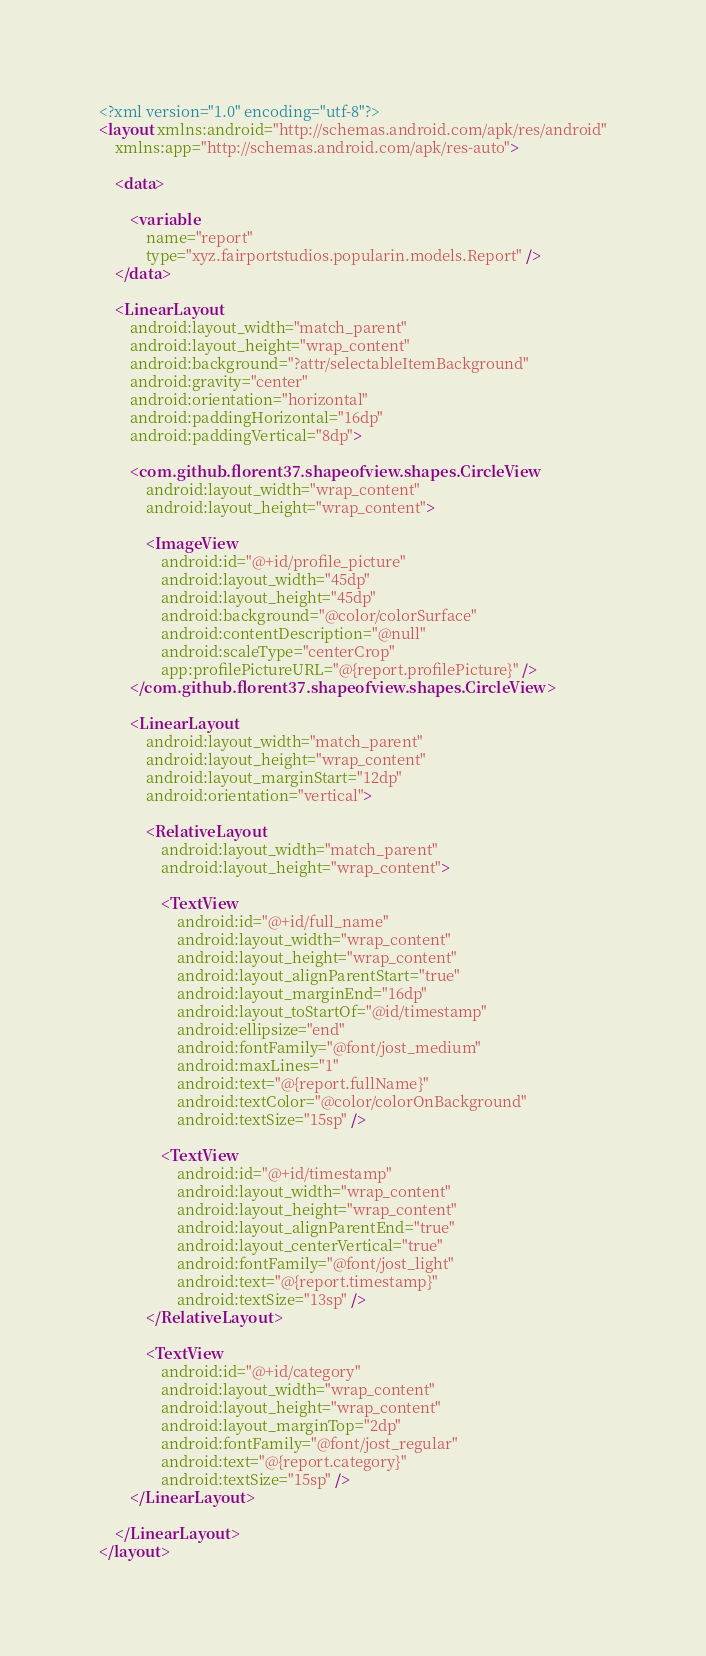<code> <loc_0><loc_0><loc_500><loc_500><_XML_><?xml version="1.0" encoding="utf-8"?>
<layout xmlns:android="http://schemas.android.com/apk/res/android"
    xmlns:app="http://schemas.android.com/apk/res-auto">

    <data>

        <variable
            name="report"
            type="xyz.fairportstudios.popularin.models.Report" />
    </data>

    <LinearLayout
        android:layout_width="match_parent"
        android:layout_height="wrap_content"
        android:background="?attr/selectableItemBackground"
        android:gravity="center"
        android:orientation="horizontal"
        android:paddingHorizontal="16dp"
        android:paddingVertical="8dp">

        <com.github.florent37.shapeofview.shapes.CircleView
            android:layout_width="wrap_content"
            android:layout_height="wrap_content">

            <ImageView
                android:id="@+id/profile_picture"
                android:layout_width="45dp"
                android:layout_height="45dp"
                android:background="@color/colorSurface"
                android:contentDescription="@null"
                android:scaleType="centerCrop"
                app:profilePictureURL="@{report.profilePicture}" />
        </com.github.florent37.shapeofview.shapes.CircleView>

        <LinearLayout
            android:layout_width="match_parent"
            android:layout_height="wrap_content"
            android:layout_marginStart="12dp"
            android:orientation="vertical">

            <RelativeLayout
                android:layout_width="match_parent"
                android:layout_height="wrap_content">

                <TextView
                    android:id="@+id/full_name"
                    android:layout_width="wrap_content"
                    android:layout_height="wrap_content"
                    android:layout_alignParentStart="true"
                    android:layout_marginEnd="16dp"
                    android:layout_toStartOf="@id/timestamp"
                    android:ellipsize="end"
                    android:fontFamily="@font/jost_medium"
                    android:maxLines="1"
                    android:text="@{report.fullName}"
                    android:textColor="@color/colorOnBackground"
                    android:textSize="15sp" />

                <TextView
                    android:id="@+id/timestamp"
                    android:layout_width="wrap_content"
                    android:layout_height="wrap_content"
                    android:layout_alignParentEnd="true"
                    android:layout_centerVertical="true"
                    android:fontFamily="@font/jost_light"
                    android:text="@{report.timestamp}"
                    android:textSize="13sp" />
            </RelativeLayout>

            <TextView
                android:id="@+id/category"
                android:layout_width="wrap_content"
                android:layout_height="wrap_content"
                android:layout_marginTop="2dp"
                android:fontFamily="@font/jost_regular"
                android:text="@{report.category}"
                android:textSize="15sp" />
        </LinearLayout>

    </LinearLayout>
</layout></code> 